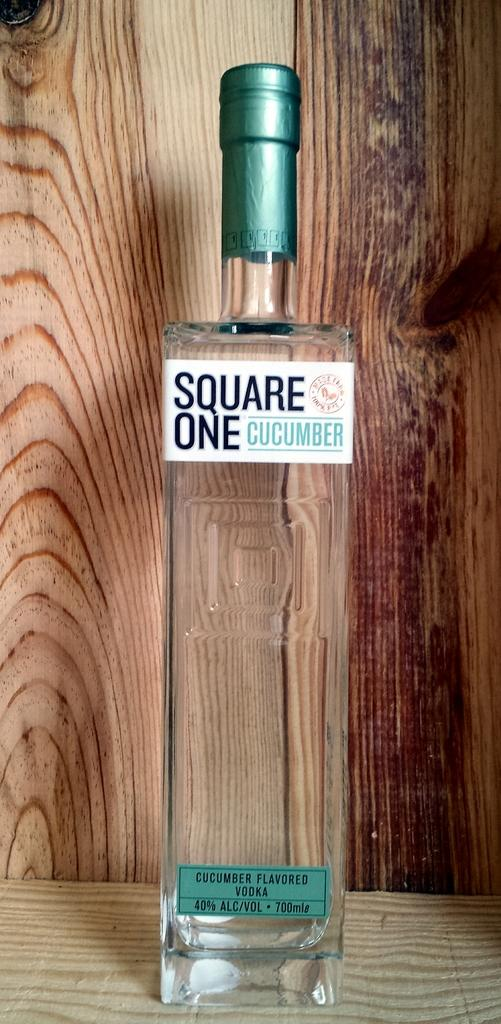<image>
Share a concise interpretation of the image provided. a close up of Square One Cucumber flavor vodka on a wood display 